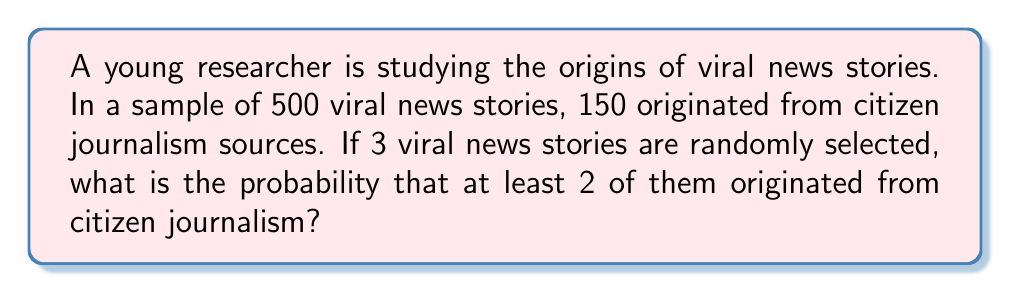Show me your answer to this math problem. Let's approach this step-by-step:

1) First, we need to calculate the probability of a single viral news story originating from citizen journalism:
   $p = \frac{150}{500} = 0.3$

2) The probability of a story not originating from citizen journalism is:
   $q = 1 - p = 0.7$

3) We want the probability of at least 2 out of 3 stories originating from citizen journalism. This can happen in two ways:
   - Exactly 2 out of 3 stories are from citizen journalism
   - All 3 stories are from citizen journalism

4) Let's calculate these probabilities using the binomial probability formula:
   $$P(X = k) = \binom{n}{k} p^k q^{n-k}$$

   Where $n$ is the number of trials, $k$ is the number of successes, $p$ is the probability of success, and $q$ is the probability of failure.

5) Probability of exactly 2 out of 3:
   $$P(X = 2) = \binom{3}{2} (0.3)^2 (0.7)^1 = 3 \cdot 0.09 \cdot 0.7 = 0.189$$

6) Probability of all 3:
   $$P(X = 3) = \binom{3}{3} (0.3)^3 (0.7)^0 = 1 \cdot 0.027 \cdot 1 = 0.027$$

7) The probability of at least 2 is the sum of these probabilities:
   $$P(X \geq 2) = P(X = 2) + P(X = 3) = 0.189 + 0.027 = 0.216$$

Therefore, the probability of at least 2 out of 3 randomly selected viral news stories originating from citizen journalism is 0.216 or 21.6%.
Answer: 0.216 